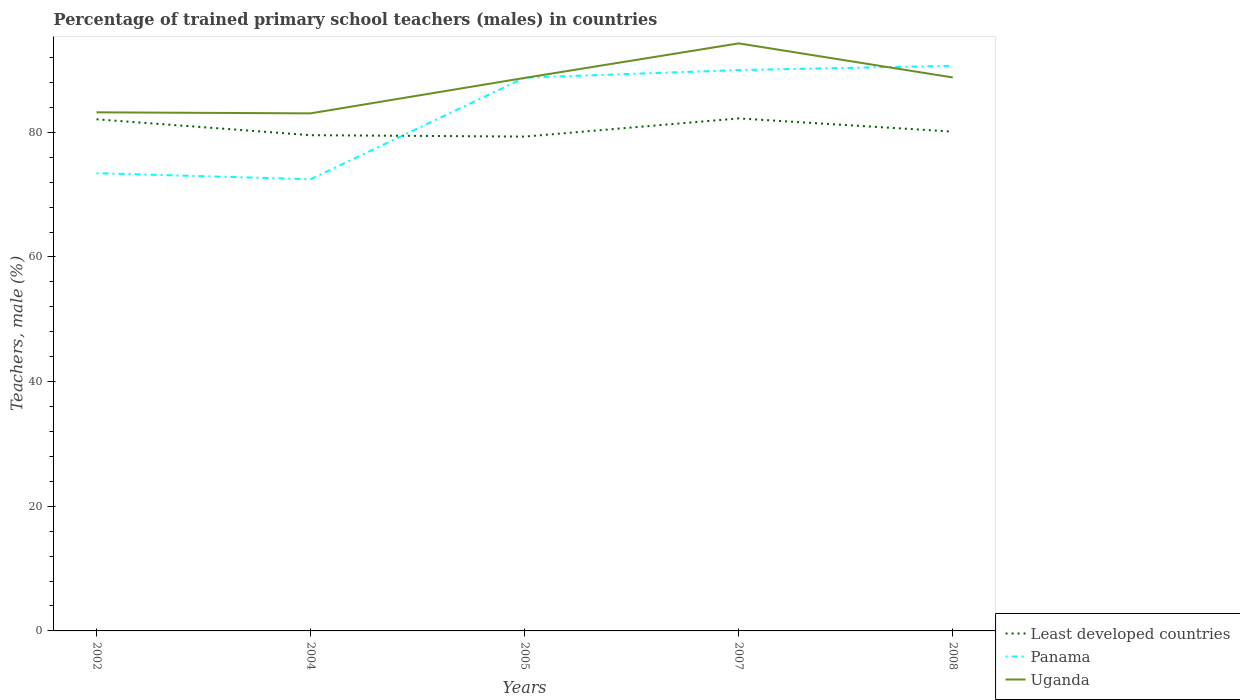How many different coloured lines are there?
Provide a short and direct response. 3. Across all years, what is the maximum percentage of trained primary school teachers (males) in Least developed countries?
Make the answer very short. 79.32. In which year was the percentage of trained primary school teachers (males) in Least developed countries maximum?
Provide a succinct answer. 2005. What is the total percentage of trained primary school teachers (males) in Panama in the graph?
Ensure brevity in your answer.  -17.52. What is the difference between the highest and the second highest percentage of trained primary school teachers (males) in Uganda?
Make the answer very short. 11.23. How many years are there in the graph?
Your answer should be very brief. 5. Are the values on the major ticks of Y-axis written in scientific E-notation?
Your response must be concise. No. Does the graph contain grids?
Keep it short and to the point. No. How many legend labels are there?
Your response must be concise. 3. How are the legend labels stacked?
Your answer should be compact. Vertical. What is the title of the graph?
Ensure brevity in your answer.  Percentage of trained primary school teachers (males) in countries. Does "Central African Republic" appear as one of the legend labels in the graph?
Keep it short and to the point. No. What is the label or title of the X-axis?
Your response must be concise. Years. What is the label or title of the Y-axis?
Offer a terse response. Teachers, male (%). What is the Teachers, male (%) of Least developed countries in 2002?
Offer a very short reply. 82.09. What is the Teachers, male (%) in Panama in 2002?
Your answer should be very brief. 73.45. What is the Teachers, male (%) in Uganda in 2002?
Your answer should be compact. 83.21. What is the Teachers, male (%) of Least developed countries in 2004?
Provide a succinct answer. 79.54. What is the Teachers, male (%) in Panama in 2004?
Offer a terse response. 72.48. What is the Teachers, male (%) in Uganda in 2004?
Offer a terse response. 83.05. What is the Teachers, male (%) of Least developed countries in 2005?
Your answer should be compact. 79.32. What is the Teachers, male (%) of Panama in 2005?
Make the answer very short. 88.78. What is the Teachers, male (%) in Uganda in 2005?
Give a very brief answer. 88.73. What is the Teachers, male (%) in Least developed countries in 2007?
Make the answer very short. 82.24. What is the Teachers, male (%) of Panama in 2007?
Make the answer very short. 90. What is the Teachers, male (%) in Uganda in 2007?
Your answer should be very brief. 94.28. What is the Teachers, male (%) in Least developed countries in 2008?
Your response must be concise. 80.12. What is the Teachers, male (%) of Panama in 2008?
Keep it short and to the point. 90.68. What is the Teachers, male (%) in Uganda in 2008?
Give a very brief answer. 88.81. Across all years, what is the maximum Teachers, male (%) of Least developed countries?
Your answer should be very brief. 82.24. Across all years, what is the maximum Teachers, male (%) of Panama?
Make the answer very short. 90.68. Across all years, what is the maximum Teachers, male (%) of Uganda?
Keep it short and to the point. 94.28. Across all years, what is the minimum Teachers, male (%) of Least developed countries?
Provide a short and direct response. 79.32. Across all years, what is the minimum Teachers, male (%) in Panama?
Provide a short and direct response. 72.48. Across all years, what is the minimum Teachers, male (%) in Uganda?
Keep it short and to the point. 83.05. What is the total Teachers, male (%) of Least developed countries in the graph?
Your answer should be compact. 403.31. What is the total Teachers, male (%) in Panama in the graph?
Offer a very short reply. 415.38. What is the total Teachers, male (%) of Uganda in the graph?
Keep it short and to the point. 438.08. What is the difference between the Teachers, male (%) of Least developed countries in 2002 and that in 2004?
Offer a very short reply. 2.55. What is the difference between the Teachers, male (%) in Panama in 2002 and that in 2004?
Provide a short and direct response. 0.97. What is the difference between the Teachers, male (%) of Uganda in 2002 and that in 2004?
Your answer should be very brief. 0.17. What is the difference between the Teachers, male (%) of Least developed countries in 2002 and that in 2005?
Offer a very short reply. 2.77. What is the difference between the Teachers, male (%) in Panama in 2002 and that in 2005?
Offer a terse response. -15.33. What is the difference between the Teachers, male (%) in Uganda in 2002 and that in 2005?
Make the answer very short. -5.52. What is the difference between the Teachers, male (%) of Least developed countries in 2002 and that in 2007?
Your response must be concise. -0.14. What is the difference between the Teachers, male (%) of Panama in 2002 and that in 2007?
Your answer should be very brief. -16.55. What is the difference between the Teachers, male (%) in Uganda in 2002 and that in 2007?
Your answer should be compact. -11.06. What is the difference between the Teachers, male (%) of Least developed countries in 2002 and that in 2008?
Keep it short and to the point. 1.98. What is the difference between the Teachers, male (%) of Panama in 2002 and that in 2008?
Give a very brief answer. -17.23. What is the difference between the Teachers, male (%) of Uganda in 2002 and that in 2008?
Offer a very short reply. -5.59. What is the difference between the Teachers, male (%) in Least developed countries in 2004 and that in 2005?
Keep it short and to the point. 0.23. What is the difference between the Teachers, male (%) of Panama in 2004 and that in 2005?
Your response must be concise. -16.3. What is the difference between the Teachers, male (%) in Uganda in 2004 and that in 2005?
Your response must be concise. -5.69. What is the difference between the Teachers, male (%) of Least developed countries in 2004 and that in 2007?
Give a very brief answer. -2.69. What is the difference between the Teachers, male (%) in Panama in 2004 and that in 2007?
Offer a terse response. -17.52. What is the difference between the Teachers, male (%) in Uganda in 2004 and that in 2007?
Ensure brevity in your answer.  -11.23. What is the difference between the Teachers, male (%) in Least developed countries in 2004 and that in 2008?
Give a very brief answer. -0.57. What is the difference between the Teachers, male (%) of Panama in 2004 and that in 2008?
Provide a succinct answer. -18.2. What is the difference between the Teachers, male (%) in Uganda in 2004 and that in 2008?
Ensure brevity in your answer.  -5.76. What is the difference between the Teachers, male (%) of Least developed countries in 2005 and that in 2007?
Make the answer very short. -2.92. What is the difference between the Teachers, male (%) of Panama in 2005 and that in 2007?
Keep it short and to the point. -1.22. What is the difference between the Teachers, male (%) of Uganda in 2005 and that in 2007?
Provide a succinct answer. -5.54. What is the difference between the Teachers, male (%) of Least developed countries in 2005 and that in 2008?
Provide a short and direct response. -0.8. What is the difference between the Teachers, male (%) of Panama in 2005 and that in 2008?
Offer a very short reply. -1.9. What is the difference between the Teachers, male (%) in Uganda in 2005 and that in 2008?
Make the answer very short. -0.07. What is the difference between the Teachers, male (%) of Least developed countries in 2007 and that in 2008?
Offer a terse response. 2.12. What is the difference between the Teachers, male (%) of Panama in 2007 and that in 2008?
Keep it short and to the point. -0.69. What is the difference between the Teachers, male (%) in Uganda in 2007 and that in 2008?
Provide a succinct answer. 5.47. What is the difference between the Teachers, male (%) in Least developed countries in 2002 and the Teachers, male (%) in Panama in 2004?
Make the answer very short. 9.61. What is the difference between the Teachers, male (%) in Least developed countries in 2002 and the Teachers, male (%) in Uganda in 2004?
Provide a short and direct response. -0.95. What is the difference between the Teachers, male (%) in Panama in 2002 and the Teachers, male (%) in Uganda in 2004?
Give a very brief answer. -9.6. What is the difference between the Teachers, male (%) in Least developed countries in 2002 and the Teachers, male (%) in Panama in 2005?
Your response must be concise. -6.68. What is the difference between the Teachers, male (%) in Least developed countries in 2002 and the Teachers, male (%) in Uganda in 2005?
Your answer should be very brief. -6.64. What is the difference between the Teachers, male (%) in Panama in 2002 and the Teachers, male (%) in Uganda in 2005?
Keep it short and to the point. -15.29. What is the difference between the Teachers, male (%) of Least developed countries in 2002 and the Teachers, male (%) of Panama in 2007?
Make the answer very short. -7.9. What is the difference between the Teachers, male (%) of Least developed countries in 2002 and the Teachers, male (%) of Uganda in 2007?
Your response must be concise. -12.18. What is the difference between the Teachers, male (%) in Panama in 2002 and the Teachers, male (%) in Uganda in 2007?
Offer a very short reply. -20.83. What is the difference between the Teachers, male (%) of Least developed countries in 2002 and the Teachers, male (%) of Panama in 2008?
Make the answer very short. -8.59. What is the difference between the Teachers, male (%) in Least developed countries in 2002 and the Teachers, male (%) in Uganda in 2008?
Your response must be concise. -6.71. What is the difference between the Teachers, male (%) of Panama in 2002 and the Teachers, male (%) of Uganda in 2008?
Your response must be concise. -15.36. What is the difference between the Teachers, male (%) of Least developed countries in 2004 and the Teachers, male (%) of Panama in 2005?
Provide a short and direct response. -9.23. What is the difference between the Teachers, male (%) of Least developed countries in 2004 and the Teachers, male (%) of Uganda in 2005?
Give a very brief answer. -9.19. What is the difference between the Teachers, male (%) in Panama in 2004 and the Teachers, male (%) in Uganda in 2005?
Your response must be concise. -16.26. What is the difference between the Teachers, male (%) in Least developed countries in 2004 and the Teachers, male (%) in Panama in 2007?
Provide a succinct answer. -10.45. What is the difference between the Teachers, male (%) in Least developed countries in 2004 and the Teachers, male (%) in Uganda in 2007?
Make the answer very short. -14.73. What is the difference between the Teachers, male (%) in Panama in 2004 and the Teachers, male (%) in Uganda in 2007?
Your response must be concise. -21.8. What is the difference between the Teachers, male (%) in Least developed countries in 2004 and the Teachers, male (%) in Panama in 2008?
Your answer should be very brief. -11.14. What is the difference between the Teachers, male (%) of Least developed countries in 2004 and the Teachers, male (%) of Uganda in 2008?
Keep it short and to the point. -9.26. What is the difference between the Teachers, male (%) in Panama in 2004 and the Teachers, male (%) in Uganda in 2008?
Keep it short and to the point. -16.33. What is the difference between the Teachers, male (%) in Least developed countries in 2005 and the Teachers, male (%) in Panama in 2007?
Your answer should be compact. -10.68. What is the difference between the Teachers, male (%) in Least developed countries in 2005 and the Teachers, male (%) in Uganda in 2007?
Provide a succinct answer. -14.96. What is the difference between the Teachers, male (%) of Panama in 2005 and the Teachers, male (%) of Uganda in 2007?
Make the answer very short. -5.5. What is the difference between the Teachers, male (%) of Least developed countries in 2005 and the Teachers, male (%) of Panama in 2008?
Ensure brevity in your answer.  -11.36. What is the difference between the Teachers, male (%) in Least developed countries in 2005 and the Teachers, male (%) in Uganda in 2008?
Ensure brevity in your answer.  -9.49. What is the difference between the Teachers, male (%) of Panama in 2005 and the Teachers, male (%) of Uganda in 2008?
Provide a succinct answer. -0.03. What is the difference between the Teachers, male (%) in Least developed countries in 2007 and the Teachers, male (%) in Panama in 2008?
Ensure brevity in your answer.  -8.45. What is the difference between the Teachers, male (%) of Least developed countries in 2007 and the Teachers, male (%) of Uganda in 2008?
Give a very brief answer. -6.57. What is the difference between the Teachers, male (%) of Panama in 2007 and the Teachers, male (%) of Uganda in 2008?
Provide a succinct answer. 1.19. What is the average Teachers, male (%) of Least developed countries per year?
Offer a terse response. 80.66. What is the average Teachers, male (%) in Panama per year?
Your response must be concise. 83.08. What is the average Teachers, male (%) in Uganda per year?
Give a very brief answer. 87.62. In the year 2002, what is the difference between the Teachers, male (%) in Least developed countries and Teachers, male (%) in Panama?
Keep it short and to the point. 8.64. In the year 2002, what is the difference between the Teachers, male (%) in Least developed countries and Teachers, male (%) in Uganda?
Your answer should be compact. -1.12. In the year 2002, what is the difference between the Teachers, male (%) of Panama and Teachers, male (%) of Uganda?
Give a very brief answer. -9.76. In the year 2004, what is the difference between the Teachers, male (%) of Least developed countries and Teachers, male (%) of Panama?
Your response must be concise. 7.07. In the year 2004, what is the difference between the Teachers, male (%) in Least developed countries and Teachers, male (%) in Uganda?
Your answer should be very brief. -3.5. In the year 2004, what is the difference between the Teachers, male (%) of Panama and Teachers, male (%) of Uganda?
Your response must be concise. -10.57. In the year 2005, what is the difference between the Teachers, male (%) in Least developed countries and Teachers, male (%) in Panama?
Ensure brevity in your answer.  -9.46. In the year 2005, what is the difference between the Teachers, male (%) in Least developed countries and Teachers, male (%) in Uganda?
Your answer should be very brief. -9.42. In the year 2005, what is the difference between the Teachers, male (%) of Panama and Teachers, male (%) of Uganda?
Your answer should be compact. 0.04. In the year 2007, what is the difference between the Teachers, male (%) of Least developed countries and Teachers, male (%) of Panama?
Offer a very short reply. -7.76. In the year 2007, what is the difference between the Teachers, male (%) of Least developed countries and Teachers, male (%) of Uganda?
Provide a succinct answer. -12.04. In the year 2007, what is the difference between the Teachers, male (%) of Panama and Teachers, male (%) of Uganda?
Your answer should be compact. -4.28. In the year 2008, what is the difference between the Teachers, male (%) in Least developed countries and Teachers, male (%) in Panama?
Keep it short and to the point. -10.56. In the year 2008, what is the difference between the Teachers, male (%) of Least developed countries and Teachers, male (%) of Uganda?
Ensure brevity in your answer.  -8.69. In the year 2008, what is the difference between the Teachers, male (%) of Panama and Teachers, male (%) of Uganda?
Your answer should be compact. 1.87. What is the ratio of the Teachers, male (%) of Least developed countries in 2002 to that in 2004?
Ensure brevity in your answer.  1.03. What is the ratio of the Teachers, male (%) of Panama in 2002 to that in 2004?
Ensure brevity in your answer.  1.01. What is the ratio of the Teachers, male (%) of Least developed countries in 2002 to that in 2005?
Offer a very short reply. 1.03. What is the ratio of the Teachers, male (%) of Panama in 2002 to that in 2005?
Give a very brief answer. 0.83. What is the ratio of the Teachers, male (%) of Uganda in 2002 to that in 2005?
Give a very brief answer. 0.94. What is the ratio of the Teachers, male (%) in Panama in 2002 to that in 2007?
Your answer should be very brief. 0.82. What is the ratio of the Teachers, male (%) in Uganda in 2002 to that in 2007?
Give a very brief answer. 0.88. What is the ratio of the Teachers, male (%) of Least developed countries in 2002 to that in 2008?
Your answer should be very brief. 1.02. What is the ratio of the Teachers, male (%) of Panama in 2002 to that in 2008?
Your answer should be compact. 0.81. What is the ratio of the Teachers, male (%) of Uganda in 2002 to that in 2008?
Offer a very short reply. 0.94. What is the ratio of the Teachers, male (%) of Panama in 2004 to that in 2005?
Offer a very short reply. 0.82. What is the ratio of the Teachers, male (%) in Uganda in 2004 to that in 2005?
Make the answer very short. 0.94. What is the ratio of the Teachers, male (%) in Least developed countries in 2004 to that in 2007?
Give a very brief answer. 0.97. What is the ratio of the Teachers, male (%) of Panama in 2004 to that in 2007?
Your answer should be very brief. 0.81. What is the ratio of the Teachers, male (%) of Uganda in 2004 to that in 2007?
Your answer should be compact. 0.88. What is the ratio of the Teachers, male (%) in Panama in 2004 to that in 2008?
Keep it short and to the point. 0.8. What is the ratio of the Teachers, male (%) of Uganda in 2004 to that in 2008?
Offer a terse response. 0.94. What is the ratio of the Teachers, male (%) in Least developed countries in 2005 to that in 2007?
Offer a very short reply. 0.96. What is the ratio of the Teachers, male (%) of Panama in 2005 to that in 2007?
Offer a terse response. 0.99. What is the ratio of the Teachers, male (%) of Uganda in 2005 to that in 2007?
Provide a succinct answer. 0.94. What is the ratio of the Teachers, male (%) in Least developed countries in 2007 to that in 2008?
Provide a succinct answer. 1.03. What is the ratio of the Teachers, male (%) in Uganda in 2007 to that in 2008?
Offer a very short reply. 1.06. What is the difference between the highest and the second highest Teachers, male (%) of Least developed countries?
Your response must be concise. 0.14. What is the difference between the highest and the second highest Teachers, male (%) in Panama?
Your response must be concise. 0.69. What is the difference between the highest and the second highest Teachers, male (%) in Uganda?
Provide a succinct answer. 5.47. What is the difference between the highest and the lowest Teachers, male (%) of Least developed countries?
Keep it short and to the point. 2.92. What is the difference between the highest and the lowest Teachers, male (%) of Panama?
Ensure brevity in your answer.  18.2. What is the difference between the highest and the lowest Teachers, male (%) of Uganda?
Provide a succinct answer. 11.23. 